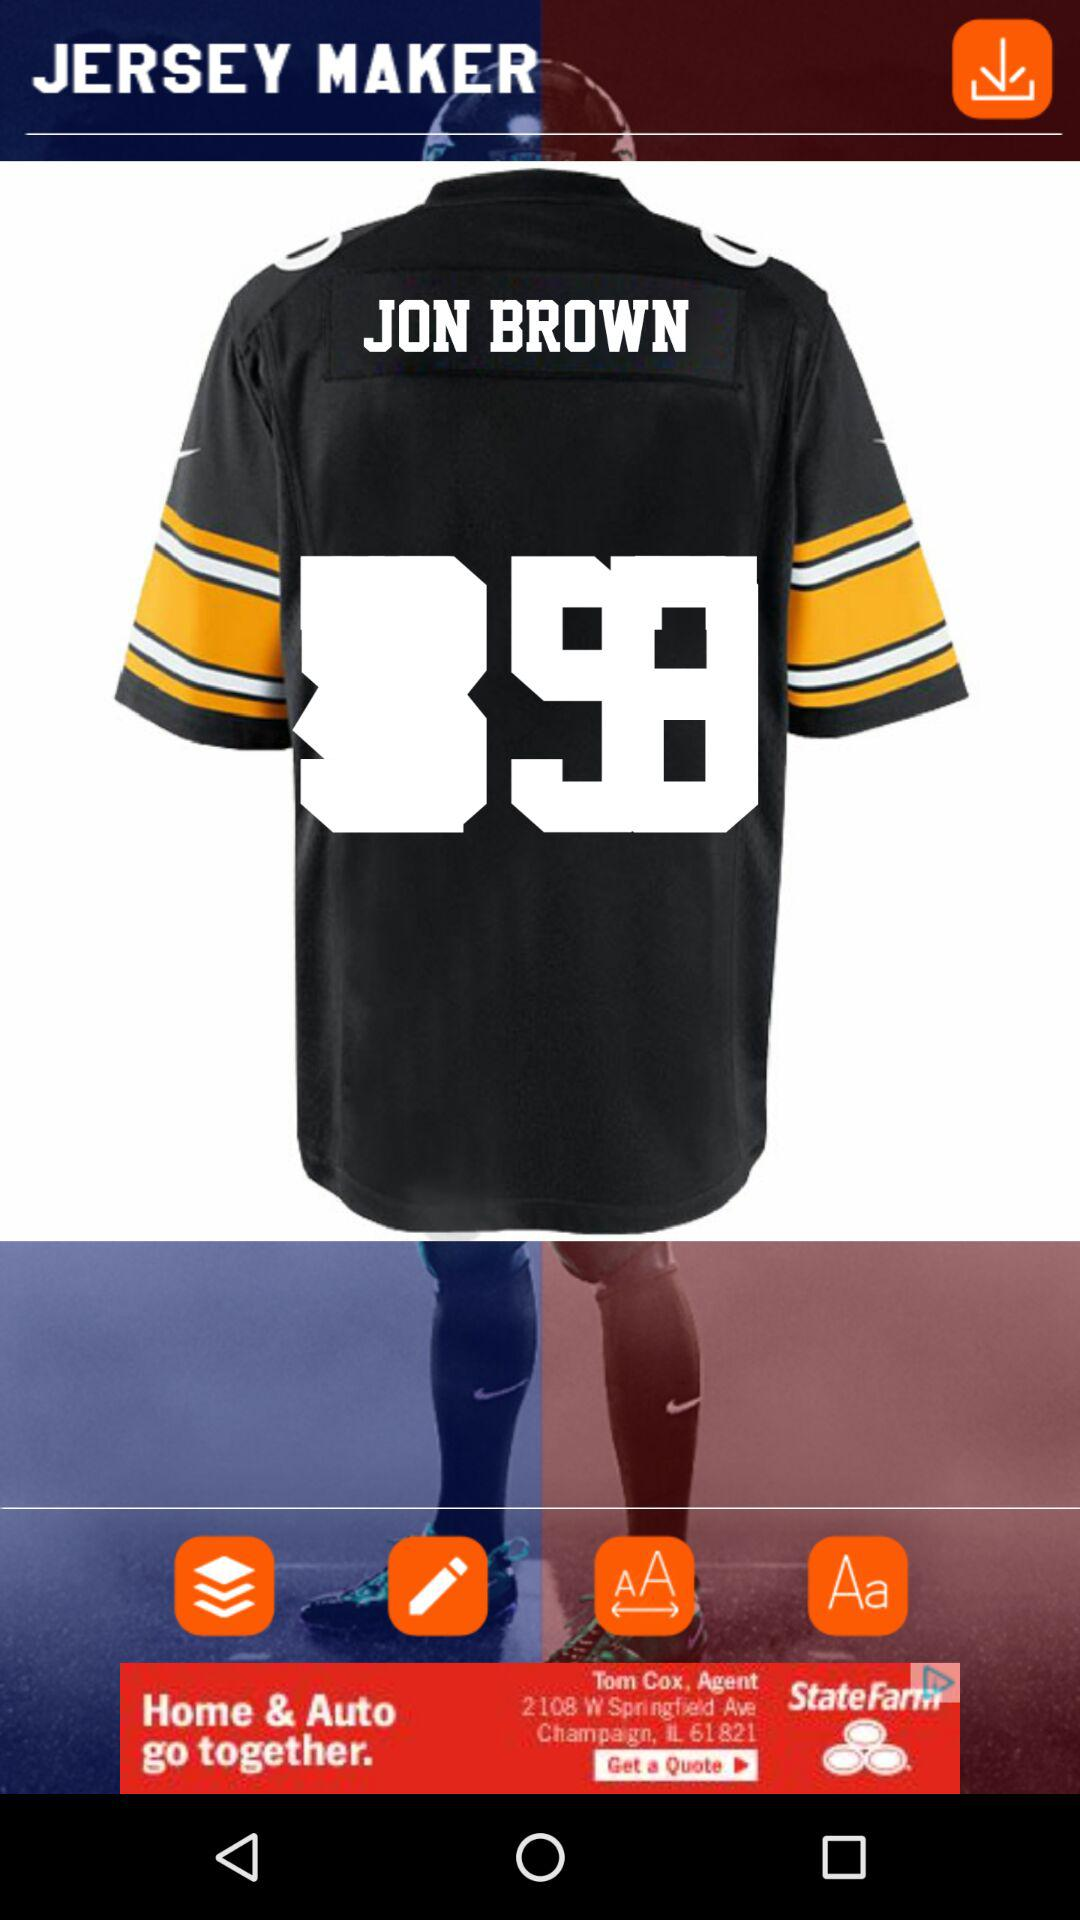What is the name written on the jersey? The name written on the jersey is Jon Brown. 